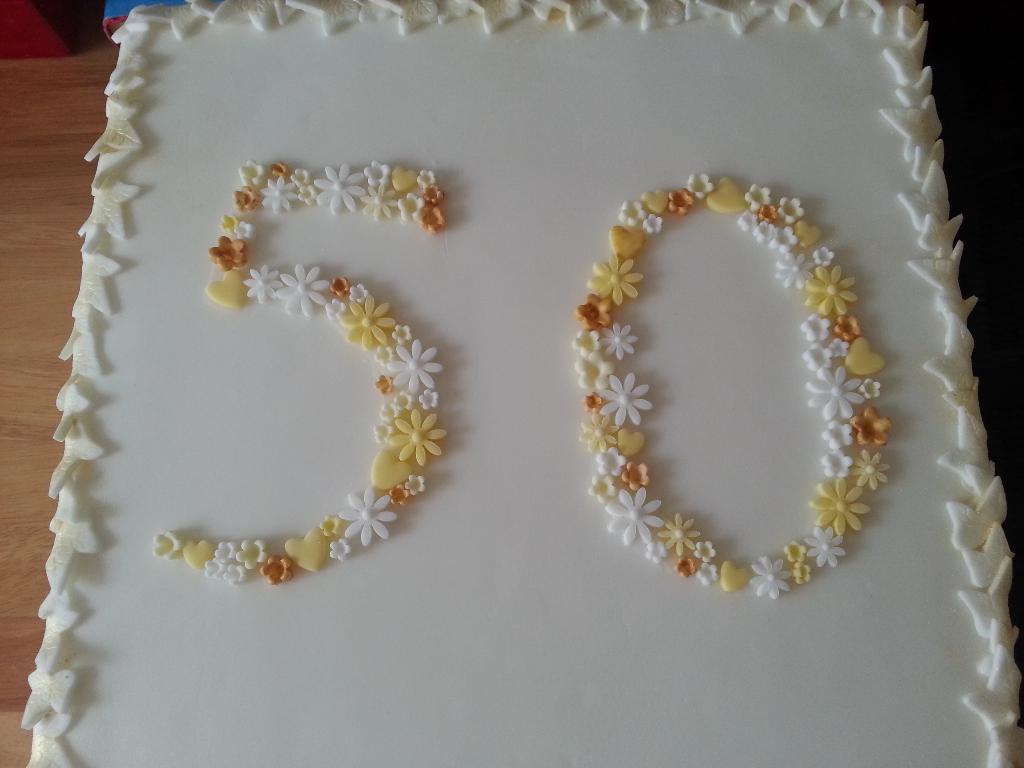Please provide a concise description of this image. In this image there is a cake on the table. On the cake there is cream carved in the structure of flowers and leaves. 